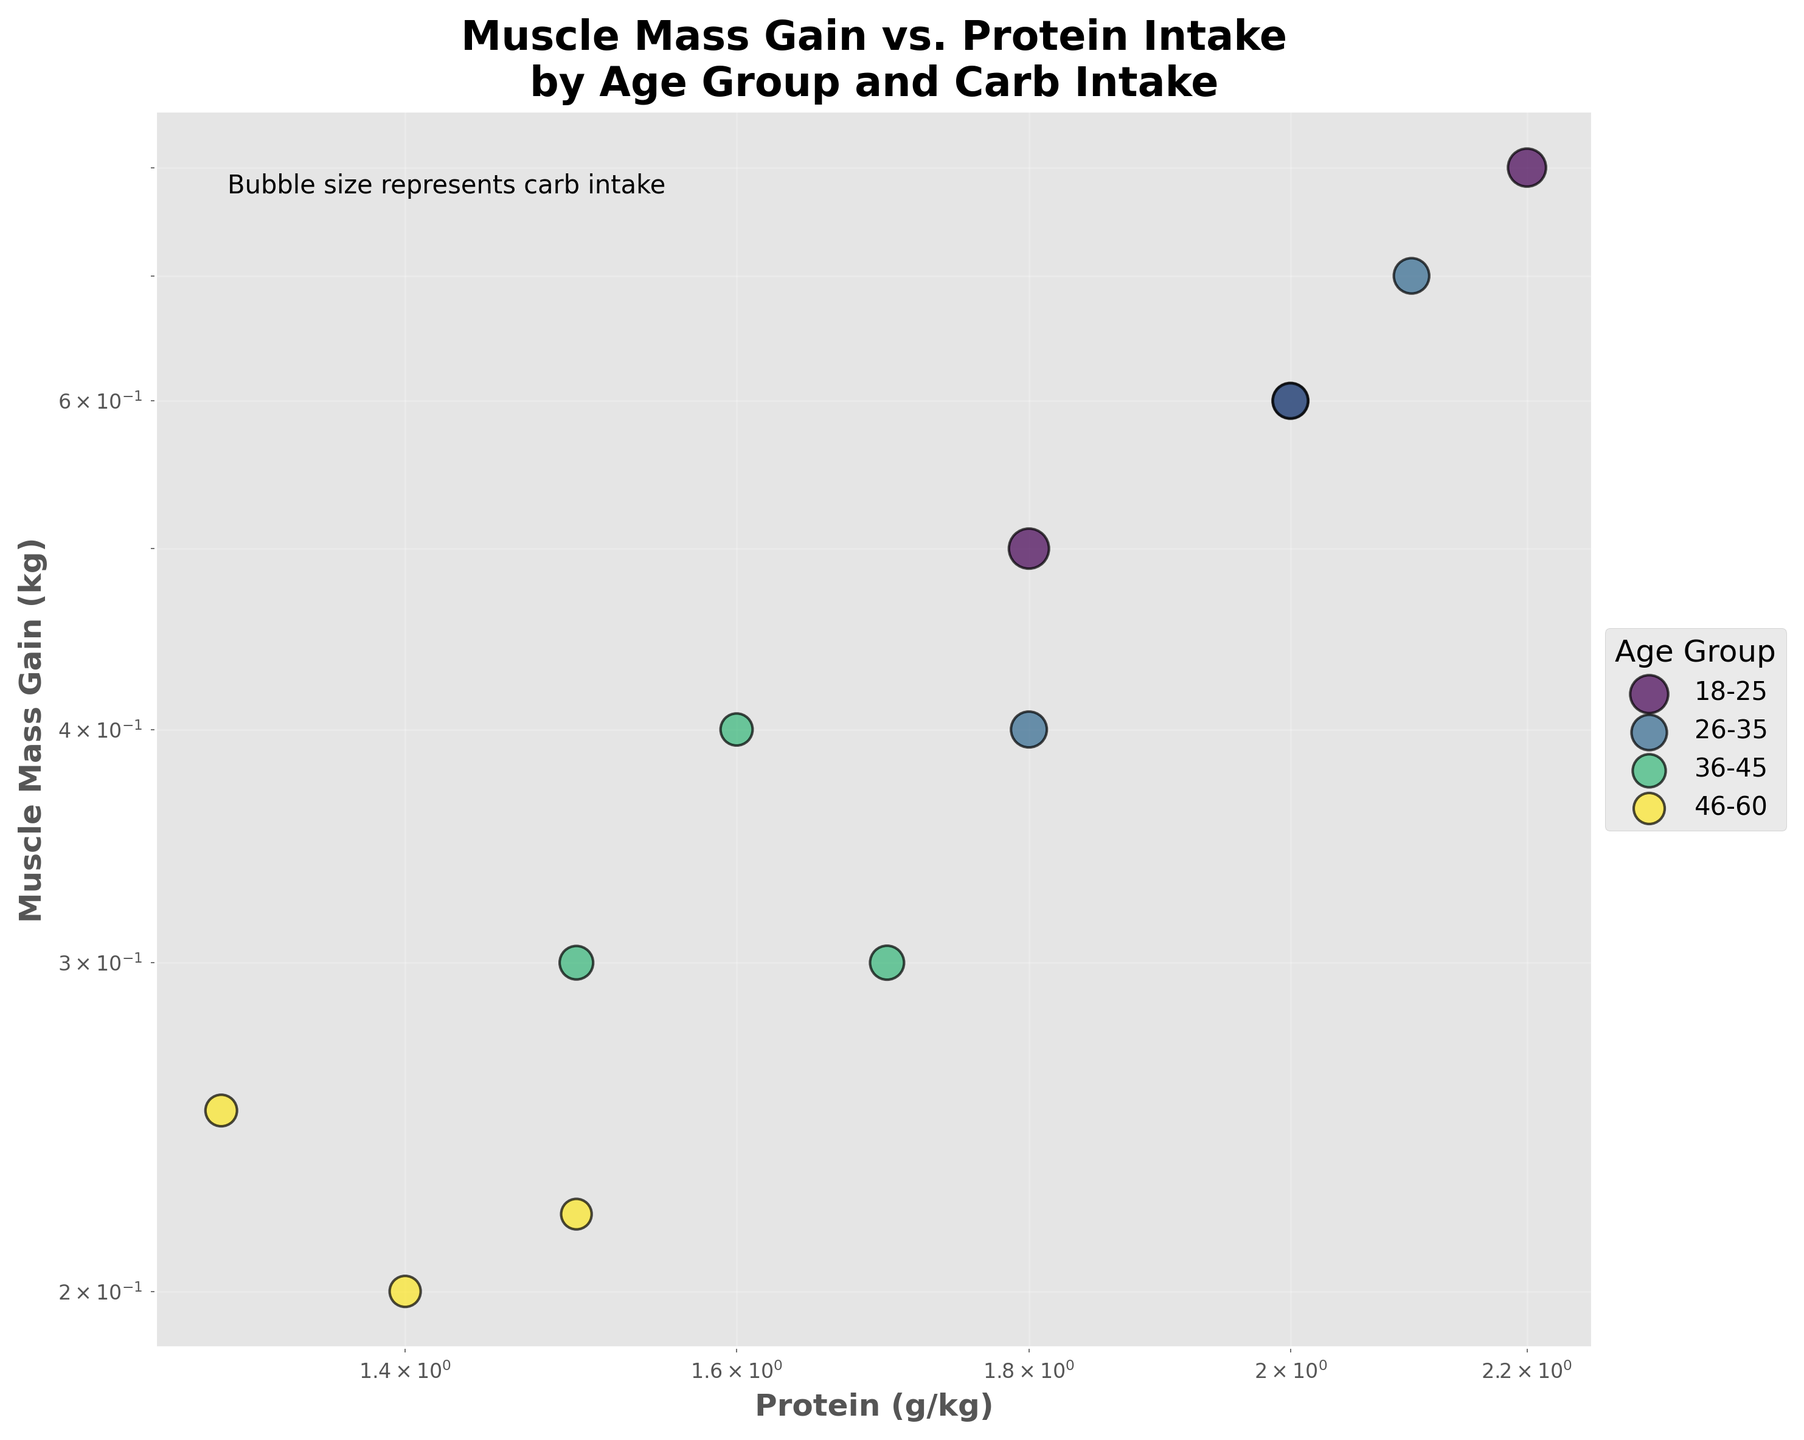What's the title of the figure? The title is usually located at the top of the figure. In this scatter plot, the title reads "Muscle Mass Gain vs. Protein Intake by Age Group and Carb Intake" as it summarizes the main topic of the plot.
Answer: Muscle Mass Gain vs. Protein Intake by Age Group and Carb Intake What do the axes represent in this plot? The x-axis represents 'Protein (g/kg)' and the y-axis represents 'Muscle Mass Gain (kg)'. These labels tell us that the plot is examining how different levels of protein intake are associated with muscle mass gain.
Answer: Protein (g/kg) and Muscle Mass Gain (kg) Which age group has the highest muscle mass gain value? The scatter points for each age group can be visually inspected on the plot. The '18-25' age group has the highest muscle mass gain value with one of the data points at 0.8 kg.
Answer: 18-25 Which age group has the most data points on the figure? By counting the number of scatter points corresponding to each age group's color in the legend, we see that each age group has three data points in the plot.
Answer: All age groups have the same number of data points (3 each) What's the relationship between carbohydrate intake and the size of the bubbles on the plot? The legend in the bottom of the plot states 'Bubble size represents carb intake'. Thus, larger bubbles indicate higher carbohydrate intake.
Answer: Larger bubbles indicate higher carb intake Which age group appears to have the lowest average muscle mass gain? By observing the position of the scatter points on the y-scale, '46-60' age group generally shows the lowest muscle mass gain values (around 0.2-0.25 kg).
Answer: 46-60 Are there any age groups that overlap in their protein intake but differ in muscle mass gain? By visually inspecting overlapping scatter points along the x-axis for 'Protein (g/kg)', we see that the '26-35' and '36-45' age groups both have protein intakes around 1.8-2.0 g/kg, but differ in muscle mass gains.
Answer: Yes What's the general trend between protein intake and muscle mass gain? Observing the scatter points from left to right (lower to higher x values), higher protein intake typically corresponds with greater muscle mass gains, as indicated by the upward trend.
Answer: Higher protein intake generally corresponds with greater muscle mass gains 